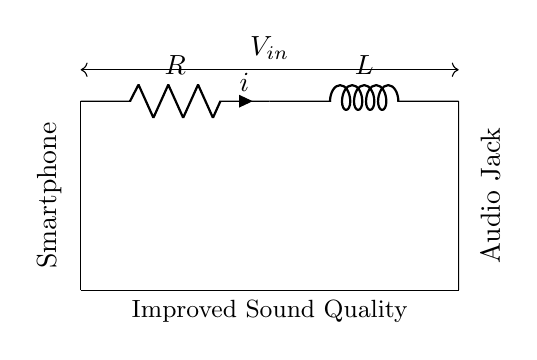What components are in the circuit? The circuit contains a resistor and an inductor, as labeled in the diagram.
Answer: Resistor and inductor What is the current symbol used in the diagram? The current is represented by the symbol "i," which shows the direction of flow from the resistor to the inductor.
Answer: i What type of circuit is represented? The circuit is an RL circuit, which stands for a circuit containing a resistor and an inductor in series.
Answer: RL circuit What is the input voltage labeled in the circuit? The input voltage is indicated by V_in, positioned above the components and showing the potential difference applied across the circuit.
Answer: V_in How does the inductor affect sound quality? The inductor helps in filtering out unwanted frequencies, which can enhance the sound quality by allowing better control of the audio signal's waveform.
Answer: Filtering unwanted frequencies What is the purpose of the resistor in the circuit? The resistor limits the current flow, which can prevent distortion in audio signals and enhance overall sound quality.
Answer: Limit current flow What is the significance of the circuit's connections to the smartphone and audio jack? The connections imply that this RL circuit is integrated into a smartphone’s audio jack to improve the audio output quality by effectively managing the signal.
Answer: Integration for improved audio output 